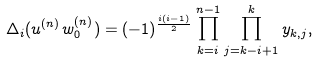<formula> <loc_0><loc_0><loc_500><loc_500>\Delta _ { i } ( u ^ { ( n ) } w _ { 0 } ^ { ( n ) } ) = ( - 1 ) ^ { \frac { i ( i - 1 ) } { 2 } } \prod _ { k = i } ^ { n - 1 } \prod _ { j = k - i + 1 } ^ { k } y _ { k , j } ,</formula> 